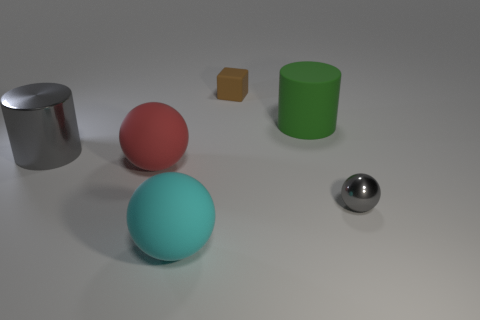Add 2 big gray metallic things. How many objects exist? 8 Subtract all cylinders. How many objects are left? 4 Add 5 rubber cubes. How many rubber cubes exist? 6 Subtract 1 gray cylinders. How many objects are left? 5 Subtract all tiny yellow balls. Subtract all red rubber objects. How many objects are left? 5 Add 2 large red objects. How many large red objects are left? 3 